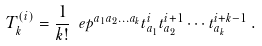Convert formula to latex. <formula><loc_0><loc_0><loc_500><loc_500>T _ { k } ^ { ( i ) } = \frac { 1 } { k ! } \ e p ^ { a _ { 1 } a _ { 2 } \dots a _ { k } } t _ { a _ { 1 } } ^ { i } t _ { a _ { 2 } } ^ { i + 1 } \cdots t _ { a _ { k } } ^ { i + k - 1 } \, .</formula> 